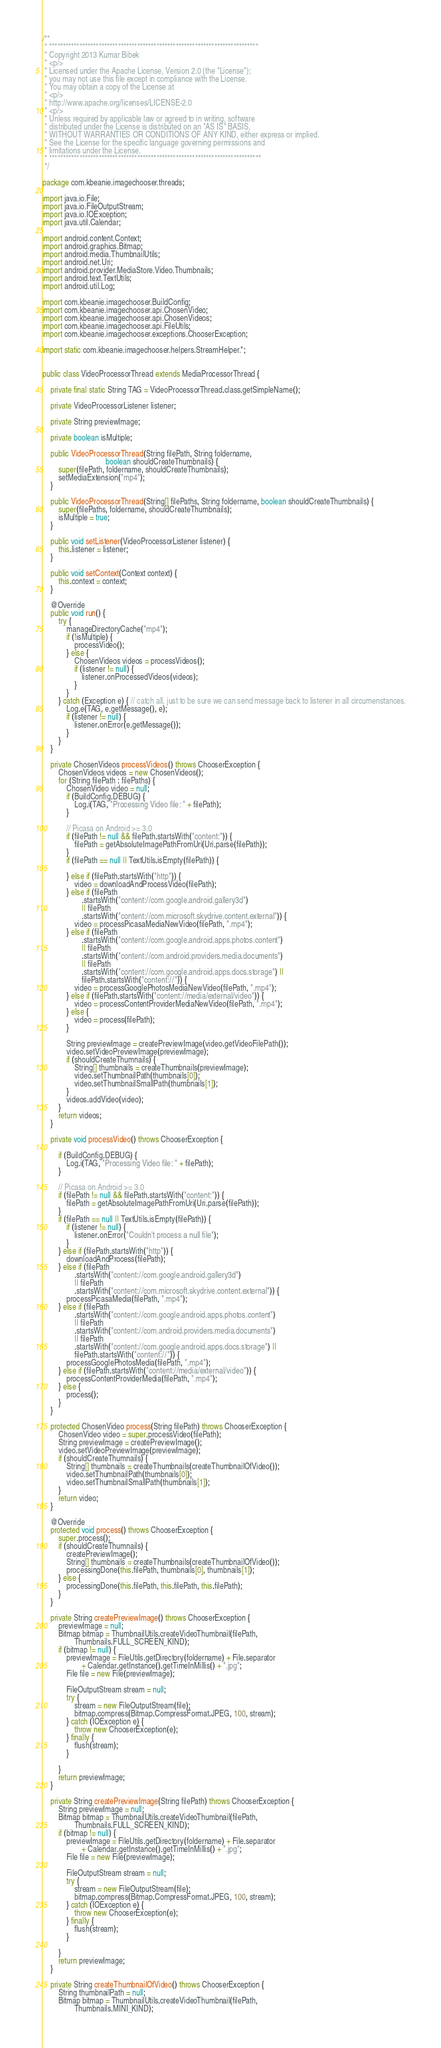<code> <loc_0><loc_0><loc_500><loc_500><_Java_>/**
 * ****************************************************************************
 * Copyright 2013 Kumar Bibek
 * <p/>
 * Licensed under the Apache License, Version 2.0 (the "License");
 * you may not use this file except in compliance with the License.
 * You may obtain a copy of the License at
 * <p/>
 * http://www.apache.org/licenses/LICENSE-2.0
 * <p/>
 * Unless required by applicable law or agreed to in writing, software
 * distributed under the License is distributed on an "AS IS" BASIS,
 * WITHOUT WARRANTIES OR CONDITIONS OF ANY KIND, either express or implied.
 * See the License for the specific language governing permissions and
 * limitations under the License.
 * *****************************************************************************
 */

package com.kbeanie.imagechooser.threads;

import java.io.File;
import java.io.FileOutputStream;
import java.io.IOException;
import java.util.Calendar;

import android.content.Context;
import android.graphics.Bitmap;
import android.media.ThumbnailUtils;
import android.net.Uri;
import android.provider.MediaStore.Video.Thumbnails;
import android.text.TextUtils;
import android.util.Log;

import com.kbeanie.imagechooser.BuildConfig;
import com.kbeanie.imagechooser.api.ChosenVideo;
import com.kbeanie.imagechooser.api.ChosenVideos;
import com.kbeanie.imagechooser.api.FileUtils;
import com.kbeanie.imagechooser.exceptions.ChooserException;

import static com.kbeanie.imagechooser.helpers.StreamHelper.*;


public class VideoProcessorThread extends MediaProcessorThread {

    private final static String TAG = VideoProcessorThread.class.getSimpleName();

    private VideoProcessorListener listener;

    private String previewImage;

    private boolean isMultiple;

    public VideoProcessorThread(String filePath, String foldername,
                                boolean shouldCreateThumbnails) {
        super(filePath, foldername, shouldCreateThumbnails);
        setMediaExtension("mp4");
    }

    public VideoProcessorThread(String[] filePaths, String foldername, boolean shouldCreateThumbnails) {
        super(filePaths, foldername, shouldCreateThumbnails);
        isMultiple = true;
    }

    public void setListener(VideoProcessorListener listener) {
        this.listener = listener;
    }

    public void setContext(Context context) {
        this.context = context;
    }

    @Override
    public void run() {
        try {
            manageDirectoryCache("mp4");
            if (!isMultiple) {
                processVideo();
            } else {
                ChosenVideos videos = processVideos();
                if (listener != null) {
                    listener.onProcessedVideos(videos);
                }
            }
        } catch (Exception e) { // catch all, just to be sure we can send message back to listener in all circumenstances.
            Log.e(TAG, e.getMessage(), e);
            if (listener != null) {
                listener.onError(e.getMessage());
            }
        }
    }

    private ChosenVideos processVideos() throws ChooserException {
        ChosenVideos videos = new ChosenVideos();
        for (String filePath : filePaths) {
            ChosenVideo video = null;
            if (BuildConfig.DEBUG) {
                Log.i(TAG, "Processing Video file: " + filePath);
            }

            // Picasa on Android >= 3.0
            if (filePath != null && filePath.startsWith("content:")) {
                filePath = getAbsoluteImagePathFromUri(Uri.parse(filePath));
            }
            if (filePath == null || TextUtils.isEmpty(filePath)) {

            } else if (filePath.startsWith("http")) {
                video = downloadAndProcessVideo(filePath);
            } else if (filePath
                    .startsWith("content://com.google.android.gallery3d")
                    || filePath
                    .startsWith("content://com.microsoft.skydrive.content.external")) {
                video = processPicasaMediaNewVideo(filePath, ".mp4");
            } else if (filePath
                    .startsWith("content://com.google.android.apps.photos.content")
                    || filePath
                    .startsWith("content://com.android.providers.media.documents")
                    || filePath
                    .startsWith("content://com.google.android.apps.docs.storage") ||
                    filePath.startsWith("content://")) {
                video = processGooglePhotosMediaNewVideo(filePath, ".mp4");
            } else if (filePath.startsWith("content://media/external/video")) {
                video = processContentProviderMediaNewVideo(filePath, ".mp4");
            } else {
                video = process(filePath);
            }

            String previewImage = createPreviewImage(video.getVideoFilePath());
            video.setVideoPreviewImage(previewImage);
            if (shouldCreateThumnails) {
                String[] thumbnails = createThumbnails(previewImage);
                video.setThumbnailPath(thumbnails[0]);
                video.setThumbnailSmallPath(thumbnails[1]);
            }
            videos.addVideo(video);
        }
        return videos;
    }

    private void processVideo() throws ChooserException {

        if (BuildConfig.DEBUG) {
            Log.i(TAG, "Processing Video file: " + filePath);
        }

        // Picasa on Android >= 3.0
        if (filePath != null && filePath.startsWith("content:")) {
            filePath = getAbsoluteImagePathFromUri(Uri.parse(filePath));
        }
        if (filePath == null || TextUtils.isEmpty(filePath)) {
            if (listener != null) {
                listener.onError("Couldn't process a null file");
            }
        } else if (filePath.startsWith("http")) {
            downloadAndProcess(filePath);
        } else if (filePath
                .startsWith("content://com.google.android.gallery3d")
                || filePath
                .startsWith("content://com.microsoft.skydrive.content.external")) {
            processPicasaMedia(filePath, ".mp4");
        } else if (filePath
                .startsWith("content://com.google.android.apps.photos.content")
                || filePath
                .startsWith("content://com.android.providers.media.documents")
                || filePath
                .startsWith("content://com.google.android.apps.docs.storage") ||
                filePath.startsWith("content://")) {
            processGooglePhotosMedia(filePath, ".mp4");
        } else if (filePath.startsWith("content://media/external/video")) {
            processContentProviderMedia(filePath, ".mp4");
        } else {
            process();
        }
    }

    protected ChosenVideo process(String filePath) throws ChooserException {
        ChosenVideo video = super.processVideo(filePath);
        String previewImage = createPreviewImage();
        video.setVideoPreviewImage(previewImage);
        if (shouldCreateThumnails) {
            String[] thumbnails = createThumbnails(createThumbnailOfVideo());
            video.setThumbnailPath(thumbnails[0]);
            video.setThumbnailSmallPath(thumbnails[1]);
        }
        return video;
    }

    @Override
    protected void process() throws ChooserException {
        super.process();
        if (shouldCreateThumnails) {
            createPreviewImage();
            String[] thumbnails = createThumbnails(createThumbnailOfVideo());
            processingDone(this.filePath, thumbnails[0], thumbnails[1]);
        } else {
            processingDone(this.filePath, this.filePath, this.filePath);
        }
    }

    private String createPreviewImage() throws ChooserException {
        previewImage = null;
        Bitmap bitmap = ThumbnailUtils.createVideoThumbnail(filePath,
                Thumbnails.FULL_SCREEN_KIND);
        if (bitmap != null) {
            previewImage = FileUtils.getDirectory(foldername) + File.separator
                    + Calendar.getInstance().getTimeInMillis() + ".jpg";
            File file = new File(previewImage);

            FileOutputStream stream = null;
            try {
                stream = new FileOutputStream(file);
                bitmap.compress(Bitmap.CompressFormat.JPEG, 100, stream);
            } catch (IOException e) {
                throw new ChooserException(e);
            } finally {
                flush(stream);
            }

        }
        return previewImage;
    }

    private String createPreviewImage(String filePath) throws ChooserException {
        String previewImage = null;
        Bitmap bitmap = ThumbnailUtils.createVideoThumbnail(filePath,
                Thumbnails.FULL_SCREEN_KIND);
        if (bitmap != null) {
            previewImage = FileUtils.getDirectory(foldername) + File.separator
                    + Calendar.getInstance().getTimeInMillis() + ".jpg";
            File file = new File(previewImage);

            FileOutputStream stream = null;
            try {
                stream = new FileOutputStream(file);
                bitmap.compress(Bitmap.CompressFormat.JPEG, 100, stream);
            } catch (IOException e) {
                throw new ChooserException(e);
            } finally {
                flush(stream);
            }

        }
        return previewImage;
    }

    private String createThumbnailOfVideo() throws ChooserException {
        String thumbnailPath = null;
        Bitmap bitmap = ThumbnailUtils.createVideoThumbnail(filePath,
                Thumbnails.MINI_KIND);</code> 